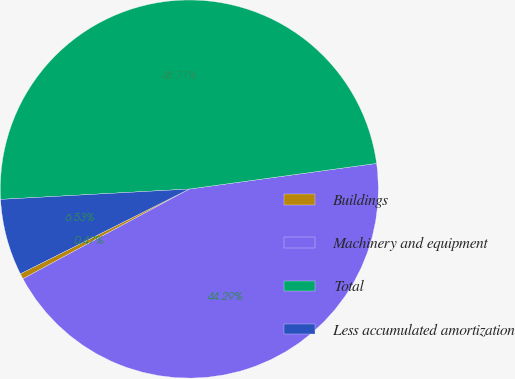<chart> <loc_0><loc_0><loc_500><loc_500><pie_chart><fcel>Buildings<fcel>Machinery and equipment<fcel>Total<fcel>Less accumulated amortization<nl><fcel>0.47%<fcel>44.29%<fcel>48.71%<fcel>6.53%<nl></chart> 